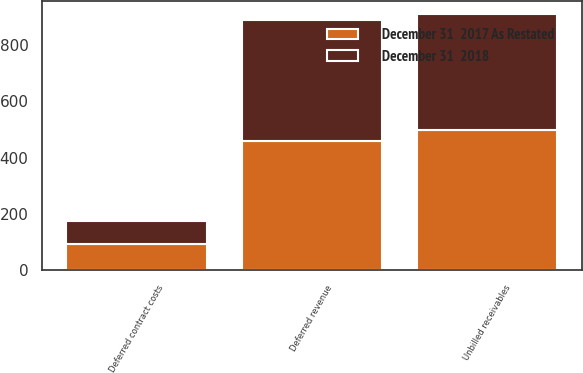Convert chart. <chart><loc_0><loc_0><loc_500><loc_500><stacked_bar_chart><ecel><fcel>Unbilled receivables<fcel>Deferred contract costs<fcel>Deferred revenue<nl><fcel>December 31  2017 As Restated<fcel>496.2<fcel>91.6<fcel>457.7<nl><fcel>December 31  2018<fcel>415.2<fcel>83.3<fcel>430.6<nl></chart> 